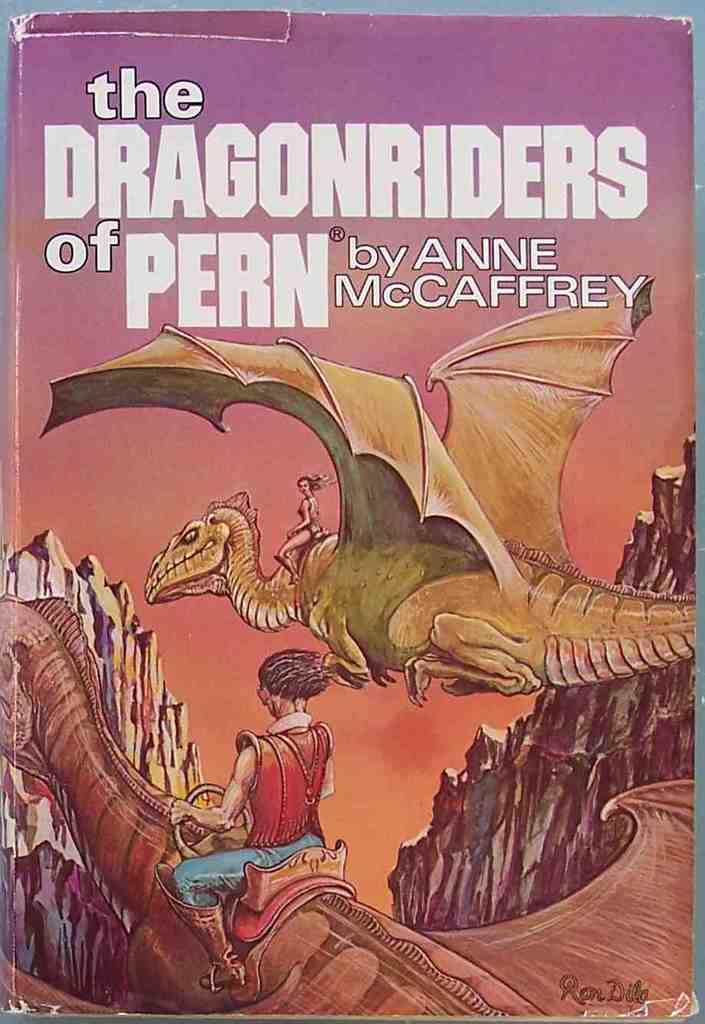What is the title of the book?
Make the answer very short. The dragonriders of pern. Who wrote this book?
Provide a short and direct response. Anne mccaffrey. 